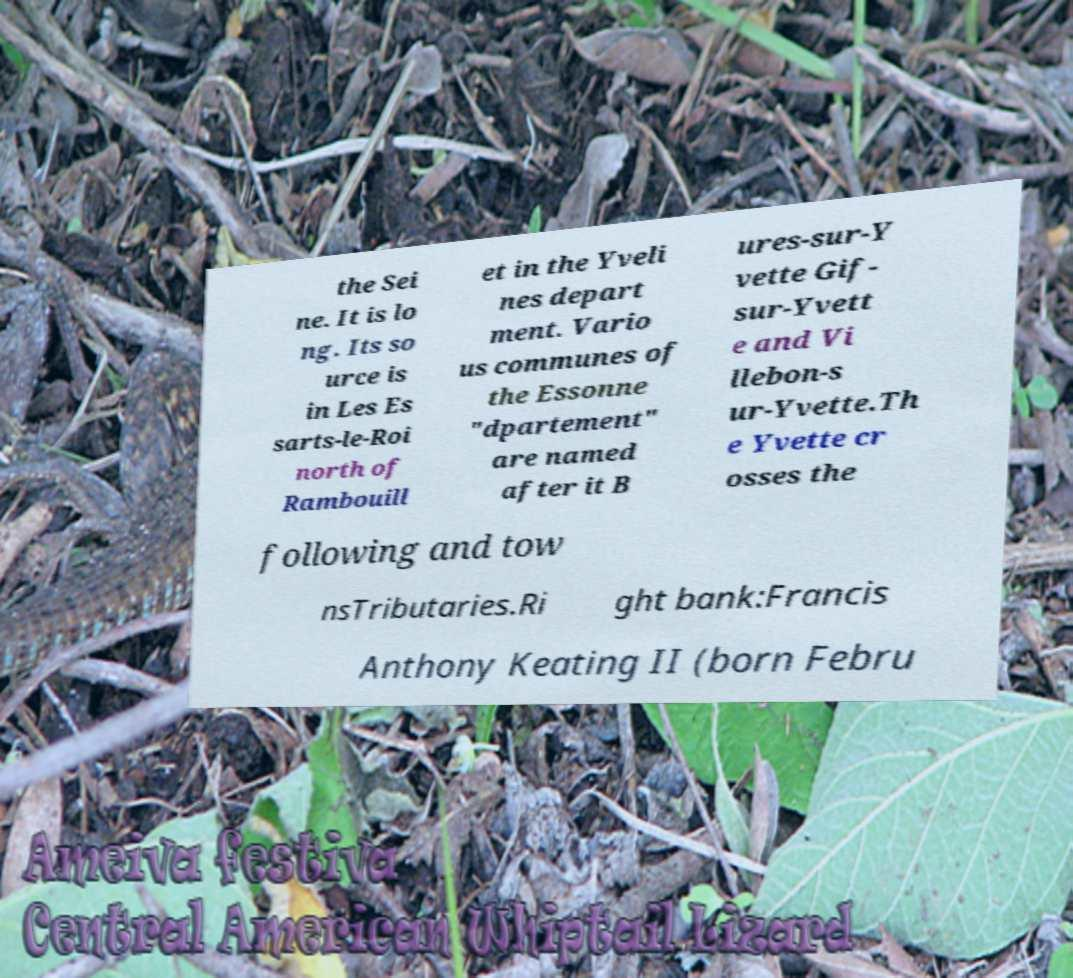Could you extract and type out the text from this image? the Sei ne. It is lo ng. Its so urce is in Les Es sarts-le-Roi north of Rambouill et in the Yveli nes depart ment. Vario us communes of the Essonne "dpartement" are named after it B ures-sur-Y vette Gif- sur-Yvett e and Vi llebon-s ur-Yvette.Th e Yvette cr osses the following and tow nsTributaries.Ri ght bank:Francis Anthony Keating II (born Febru 